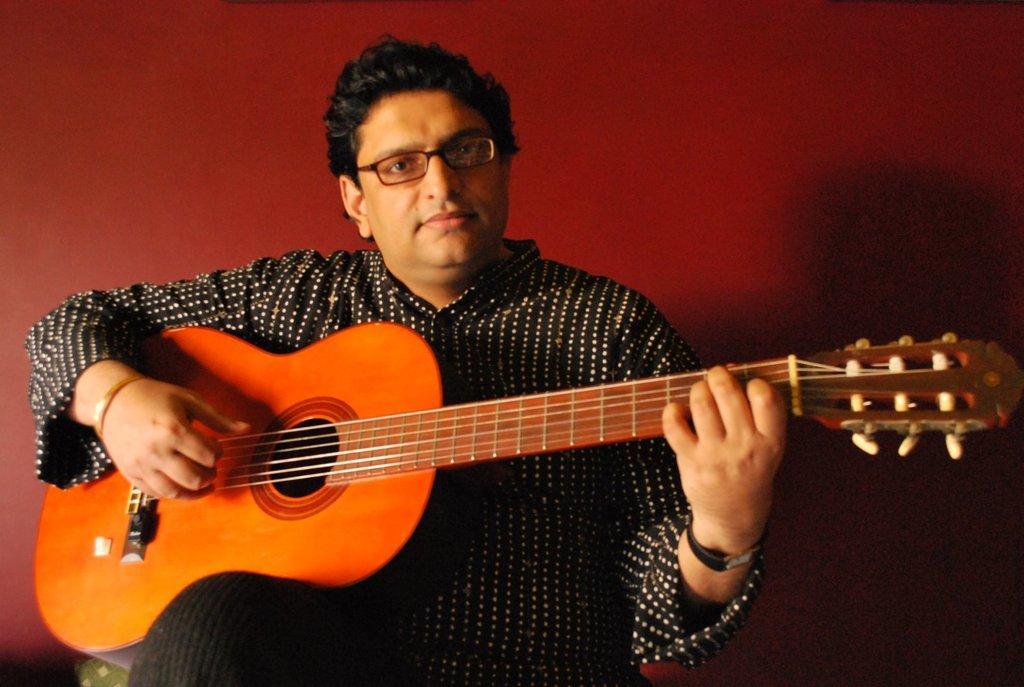Describe this image in one or two sentences. In this picture we can see a man wearing spectacles holding and playing guitar. On the background we can see a wall painted with red colour. 